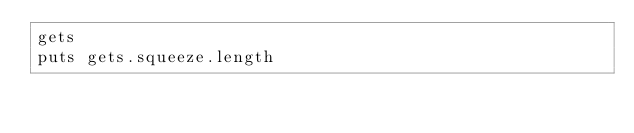<code> <loc_0><loc_0><loc_500><loc_500><_Ruby_>gets
puts gets.squeeze.length</code> 